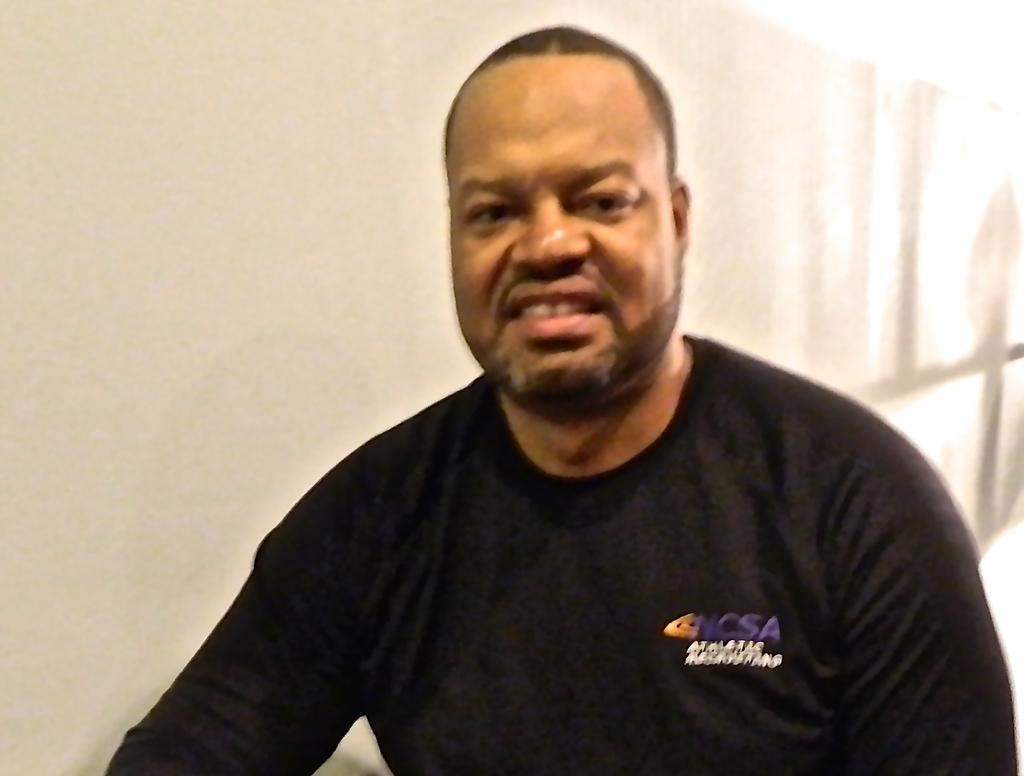Who is present in the image? There is a man in the image. What is the man wearing? The man is wearing black clothes. What can be seen behind the man in the image? The background of the image is black in color. What type of books can be found in the library depicted in the image? There is no library present in the image; it features a man wearing black clothes against a black background. 